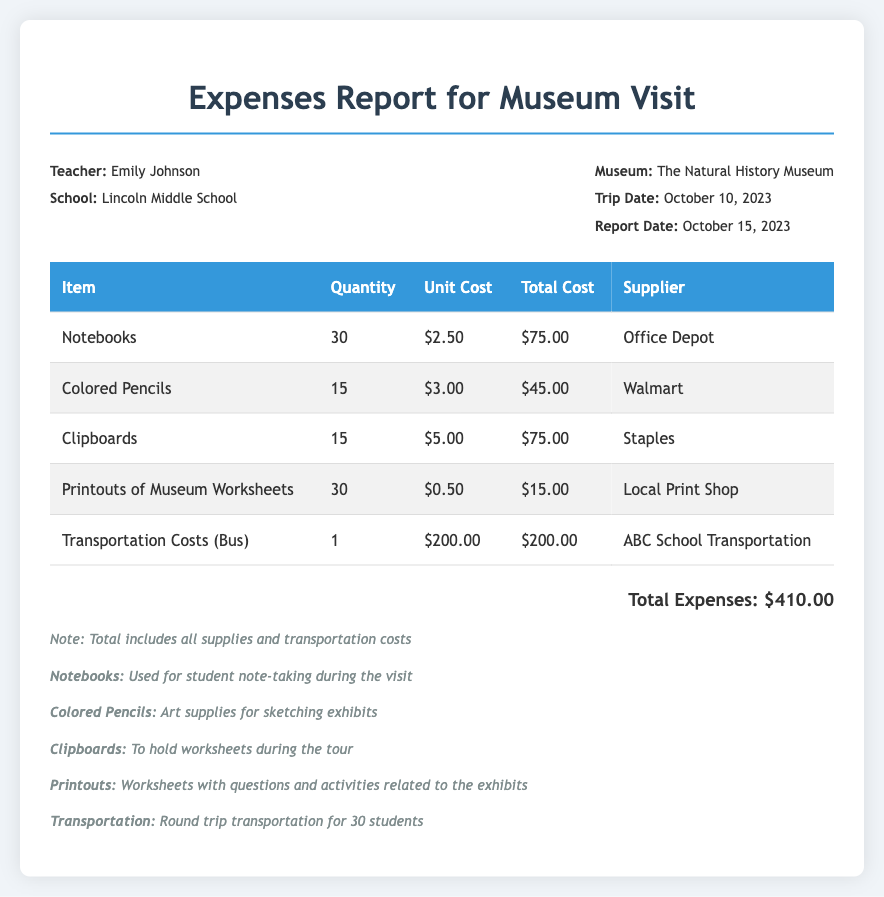What is the total cost for notebooks? The total cost for notebooks is given as $75.00 in the document.
Answer: $75.00 Who is the teacher associated with this report? The document lists Emily Johnson as the teacher for the museum visit.
Answer: Emily Johnson What was the date of the trip? The trip date is explicitly mentioned in the report as October 10, 2023.
Answer: October 10, 2023 How many clipboards were purchased? The purchase details in the table show that 15 clipboards were bought.
Answer: 15 What was the total expense for transportation costs? The report states that the transportation cost (bus) totaled $200.00.
Answer: $200.00 Which supplier provided the colored pencils? According to the document, colored pencils were supplied by Walmart.
Answer: Walmart What material was used for student note-taking? The document specifies that notebooks were used for student note-taking.
Answer: Notebooks What is the total expense amount listed in the report? The total expenses are calculated and provided as $410.00 in the report.
Answer: $410.00 What purpose do the printouts serve during the museum visit? The printouts are stated to include worksheets with questions and activities related to the exhibits.
Answer: Worksheets with questions and activities related to the exhibits 